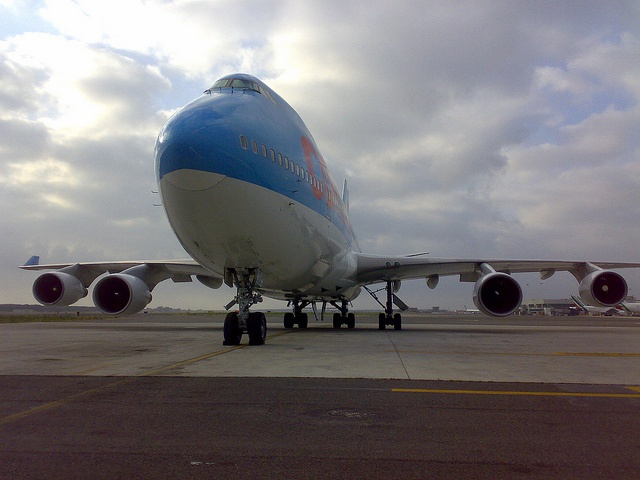Describe the objects in this image and their specific colors. I can see a airplane in white, gray, and black tones in this image. 